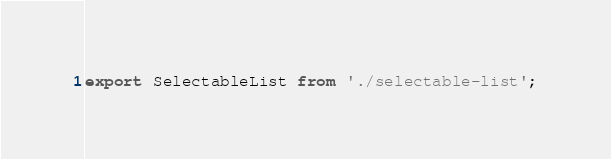Convert code to text. <code><loc_0><loc_0><loc_500><loc_500><_JavaScript_>export SelectableList from './selectable-list';
</code> 